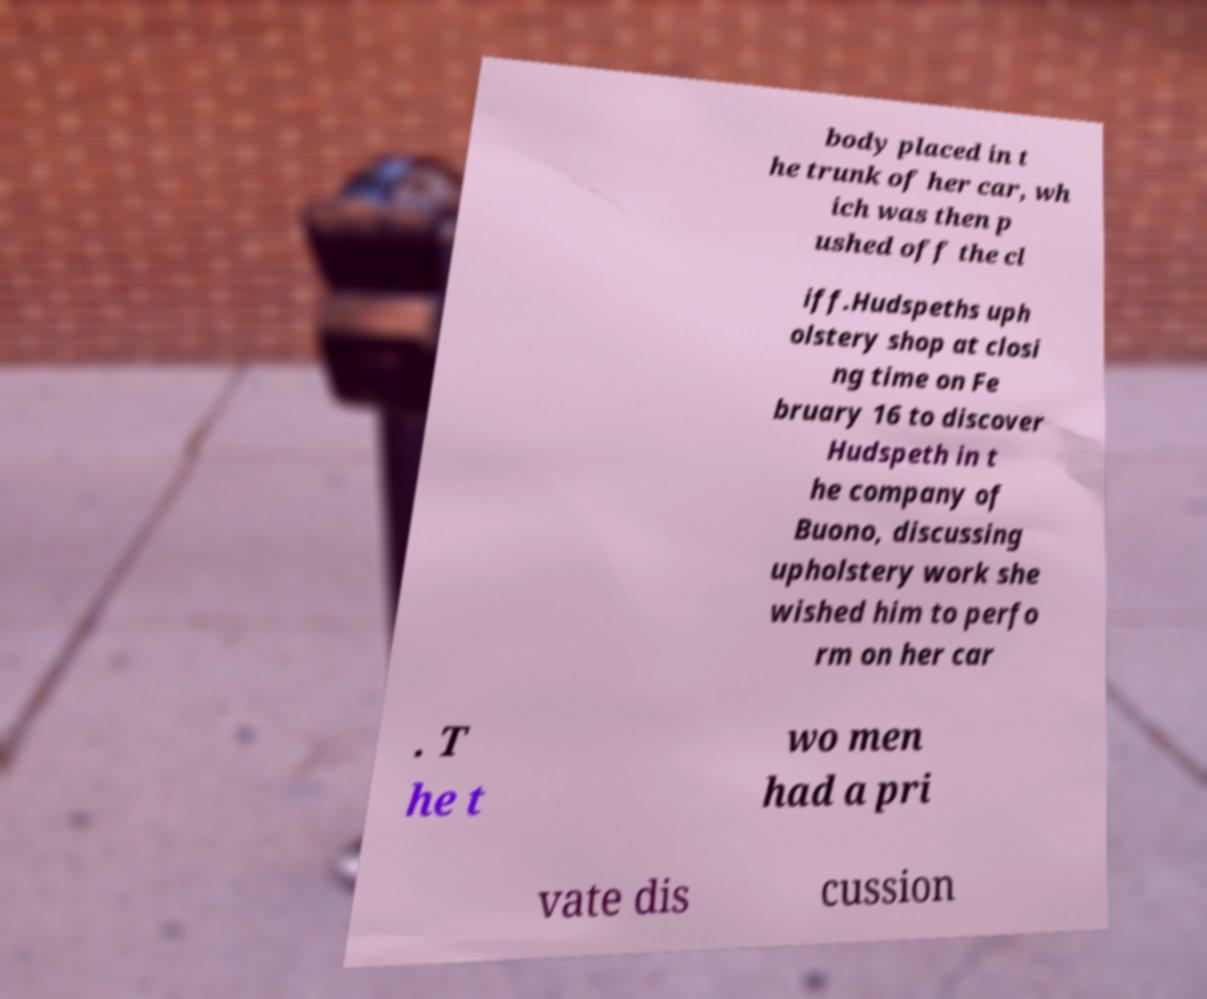Could you assist in decoding the text presented in this image and type it out clearly? body placed in t he trunk of her car, wh ich was then p ushed off the cl iff.Hudspeths uph olstery shop at closi ng time on Fe bruary 16 to discover Hudspeth in t he company of Buono, discussing upholstery work she wished him to perfo rm on her car . T he t wo men had a pri vate dis cussion 